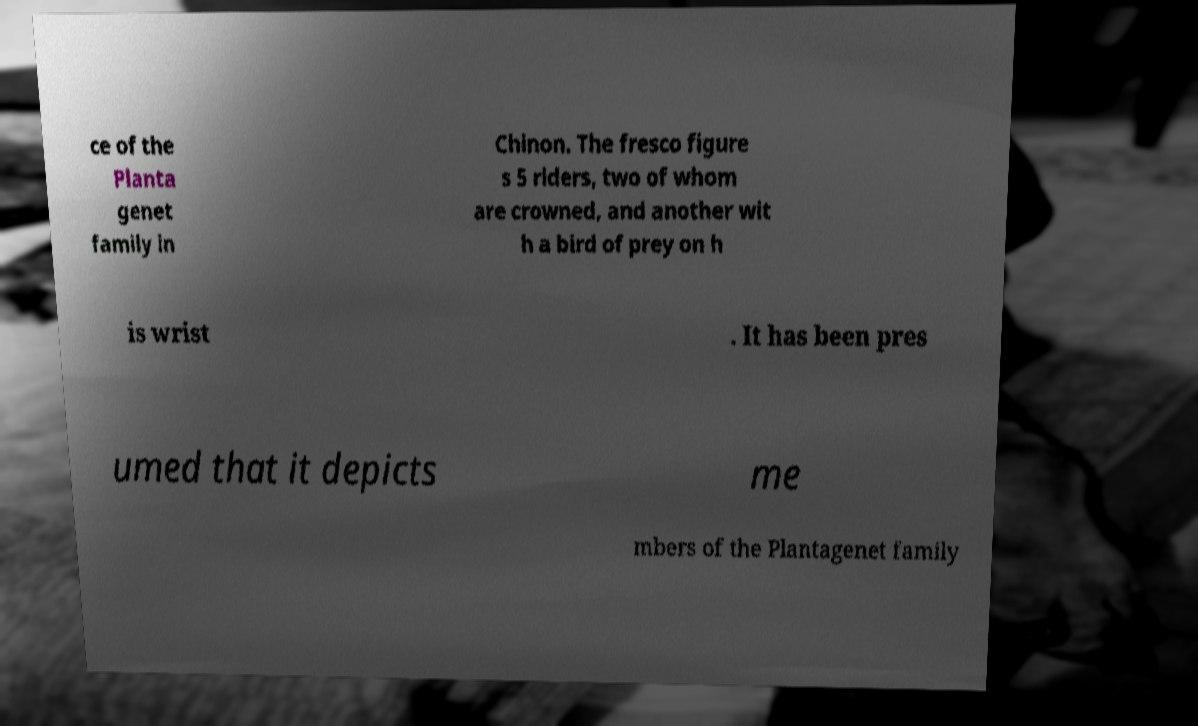For documentation purposes, I need the text within this image transcribed. Could you provide that? ce of the Planta genet family in Chinon. The fresco figure s 5 riders, two of whom are crowned, and another wit h a bird of prey on h is wrist . It has been pres umed that it depicts me mbers of the Plantagenet family 